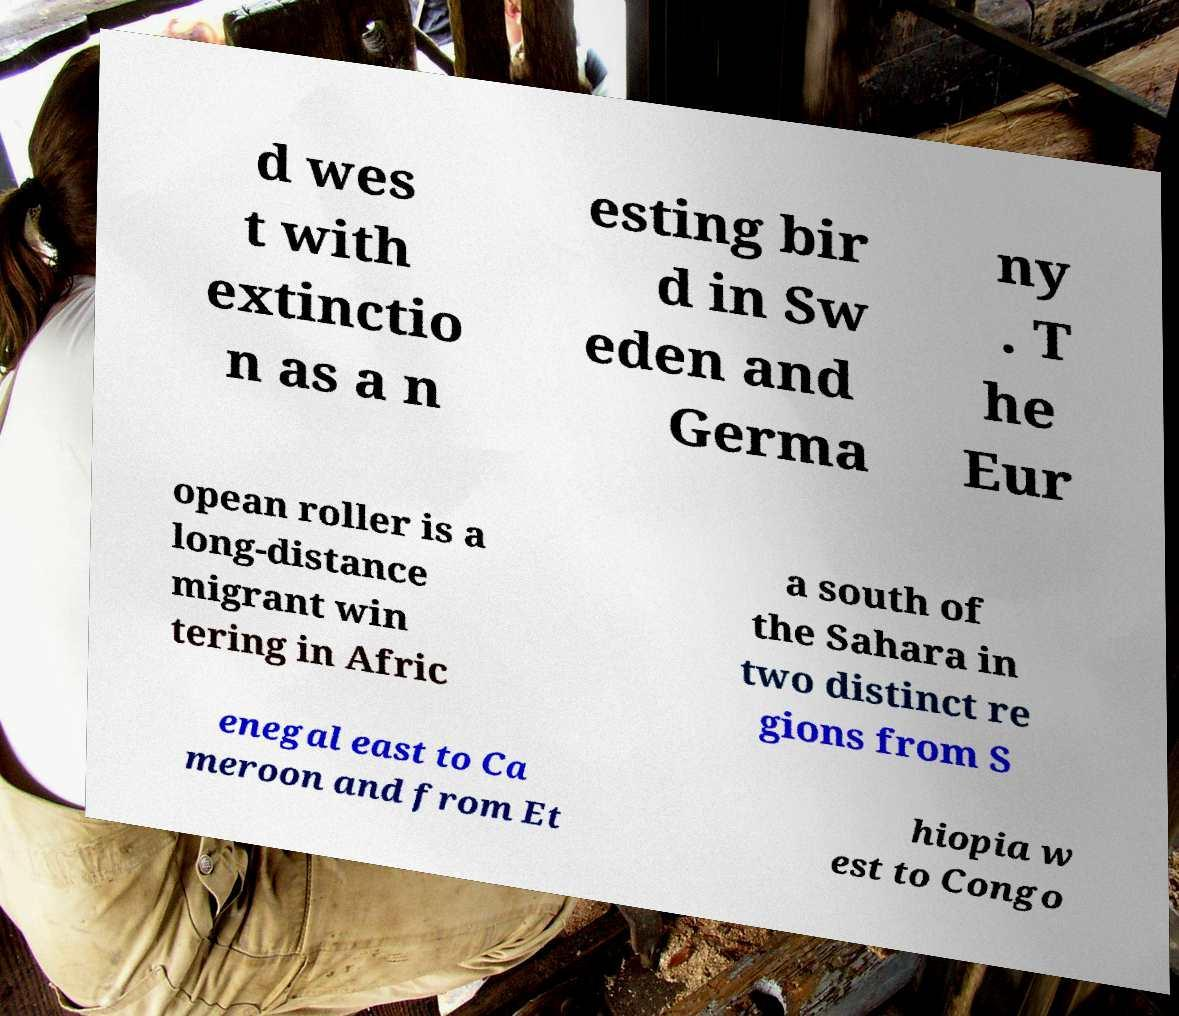Please identify and transcribe the text found in this image. d wes t with extinctio n as a n esting bir d in Sw eden and Germa ny . T he Eur opean roller is a long-distance migrant win tering in Afric a south of the Sahara in two distinct re gions from S enegal east to Ca meroon and from Et hiopia w est to Congo 